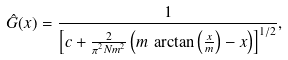<formula> <loc_0><loc_0><loc_500><loc_500>\hat { G } ( x ) = \frac { 1 } { \left [ c + \frac { 2 } { \pi ^ { 2 } N m ^ { 2 } } \left ( m \, \arctan \left ( \frac { x } { m } \right ) - x \right ) \right ] ^ { 1 / 2 } } ,</formula> 